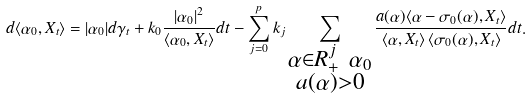Convert formula to latex. <formula><loc_0><loc_0><loc_500><loc_500>d \langle \alpha _ { 0 } , X _ { t } \rangle = | \alpha _ { 0 } | d \gamma _ { t } + k _ { 0 } \frac { | \alpha _ { 0 } | ^ { 2 } } { \langle \alpha _ { 0 } , X _ { t } \rangle } d t - \sum _ { j = 0 } ^ { p } k _ { j } \sum _ { \substack { \alpha \in R _ { + } ^ { j } \ \alpha _ { 0 } \\ a ( \alpha ) > 0 } } \frac { a ( \alpha ) \langle \alpha - \sigma _ { 0 } ( \alpha ) , X _ { t } \rangle } { \langle \alpha , X _ { t } \rangle \, \langle \sigma _ { 0 } ( \alpha ) , X _ { t } \rangle } d t .</formula> 